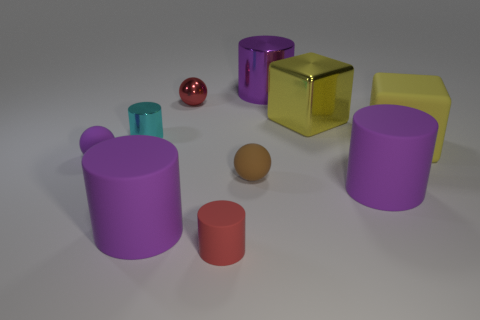What is the size of the rubber cylinder that is on the left side of the big metal cube and on the right side of the small red sphere?
Your answer should be compact. Small. How many cyan objects are made of the same material as the brown object?
Your answer should be compact. 0. The red matte thing that is the same shape as the small cyan shiny thing is what size?
Provide a succinct answer. Small. There is a small brown thing; are there any rubber things to the left of it?
Offer a terse response. Yes. What material is the red cylinder?
Your answer should be very brief. Rubber. There is a large matte thing left of the red metal ball; does it have the same color as the large metallic cylinder?
Make the answer very short. Yes. Is there any other thing that is the same shape as the brown rubber thing?
Provide a short and direct response. Yes. There is a tiny metallic thing that is the same shape as the small red rubber thing; what color is it?
Your answer should be very brief. Cyan. What is the red object behind the yellow metallic cube made of?
Give a very brief answer. Metal. What color is the matte block?
Keep it short and to the point. Yellow. 